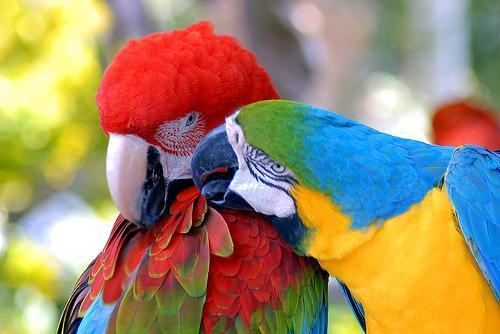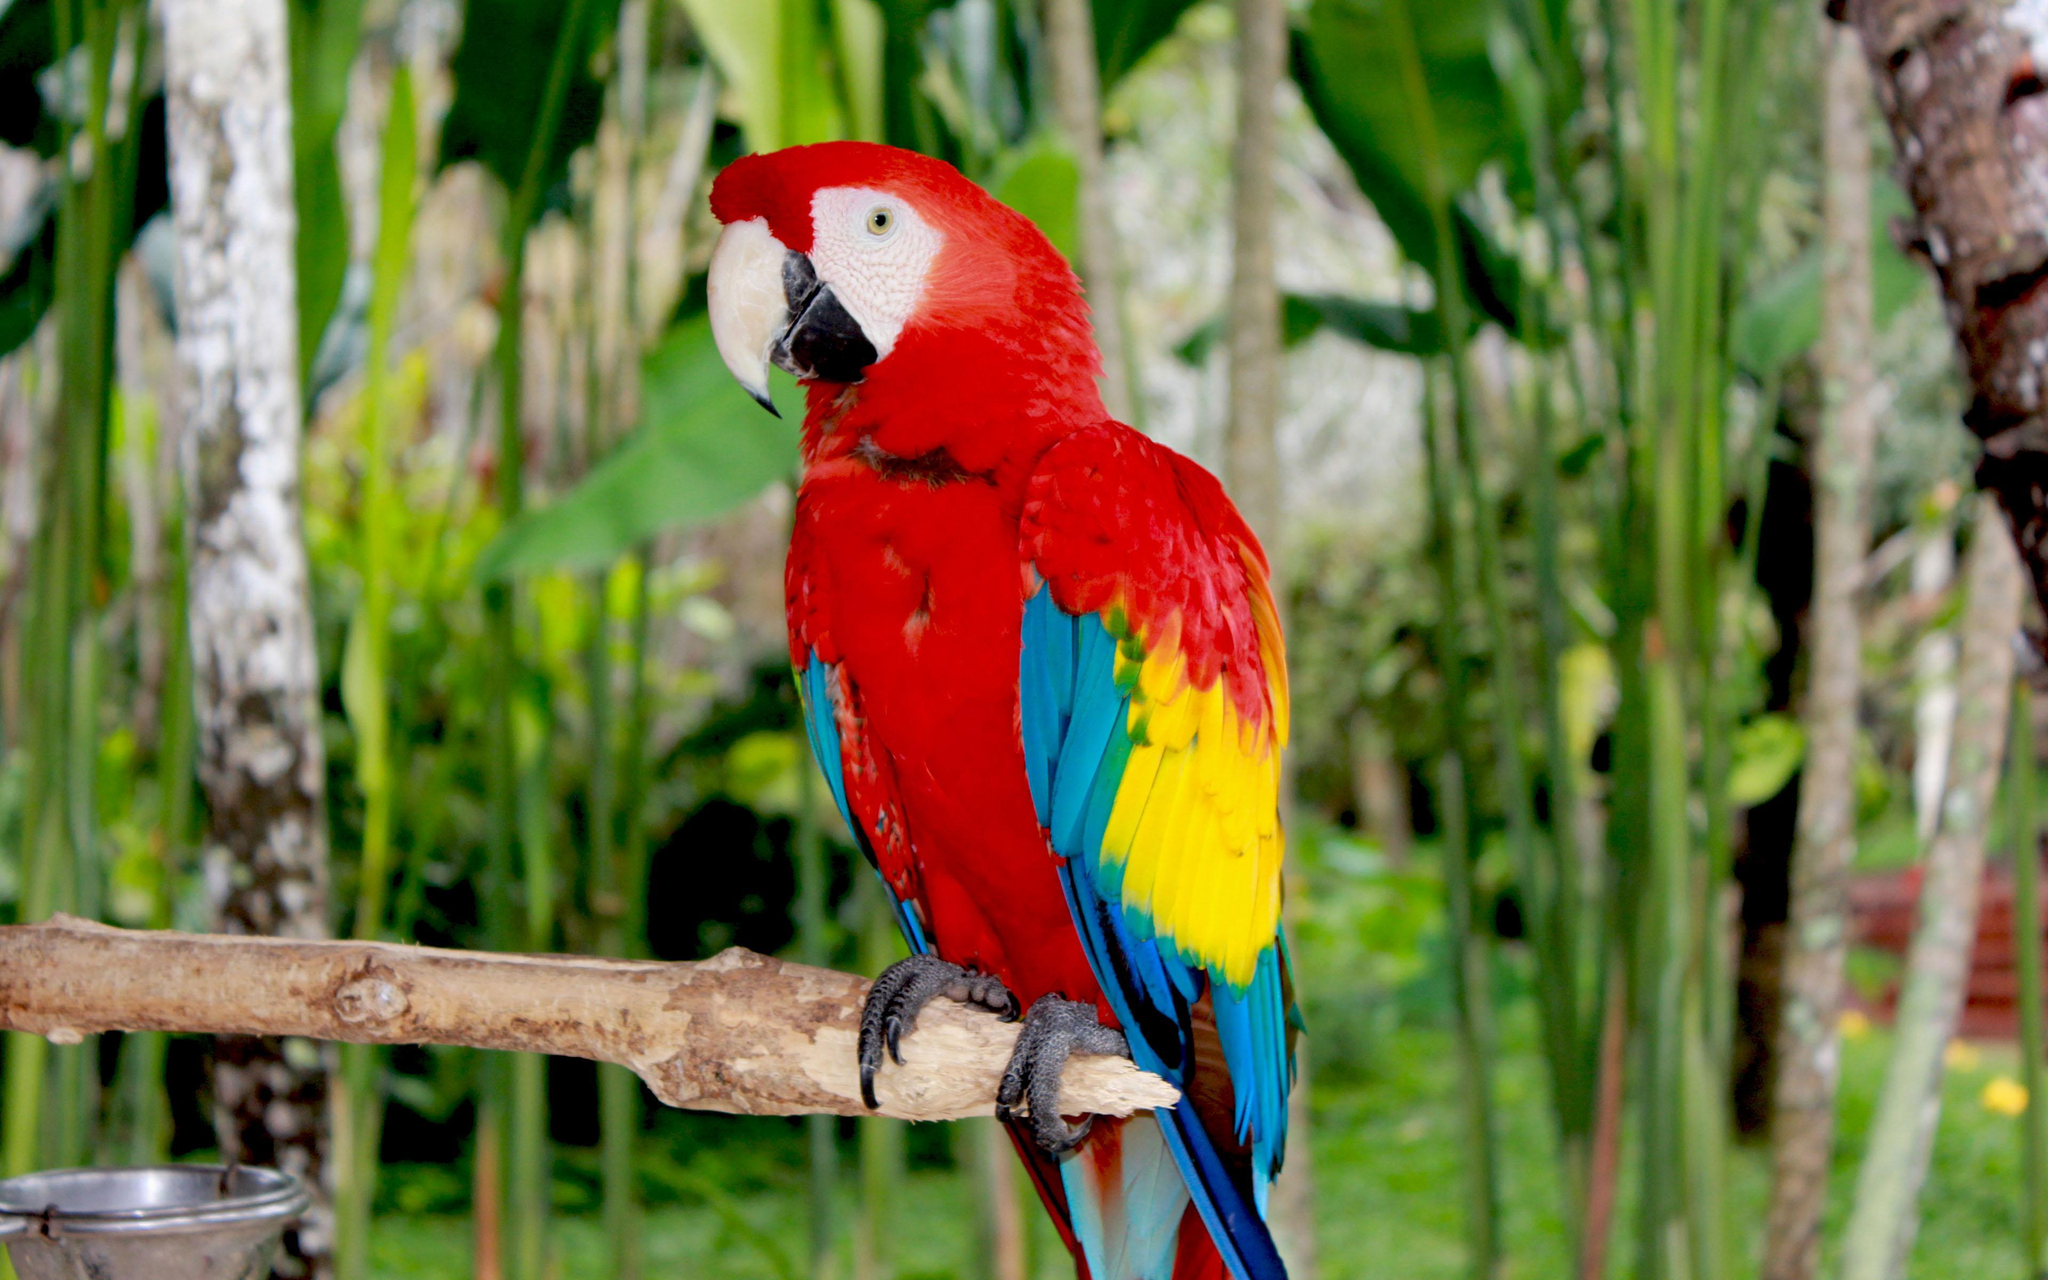The first image is the image on the left, the second image is the image on the right. Evaluate the accuracy of this statement regarding the images: "There are no more than three birds". Is it true? Answer yes or no. Yes. The first image is the image on the left, the second image is the image on the right. Evaluate the accuracy of this statement regarding the images: "More than four parrots are standing on the same stick and facing the same direction.". Is it true? Answer yes or no. No. The first image is the image on the left, the second image is the image on the right. For the images displayed, is the sentence "There are less than four birds." factually correct? Answer yes or no. Yes. 